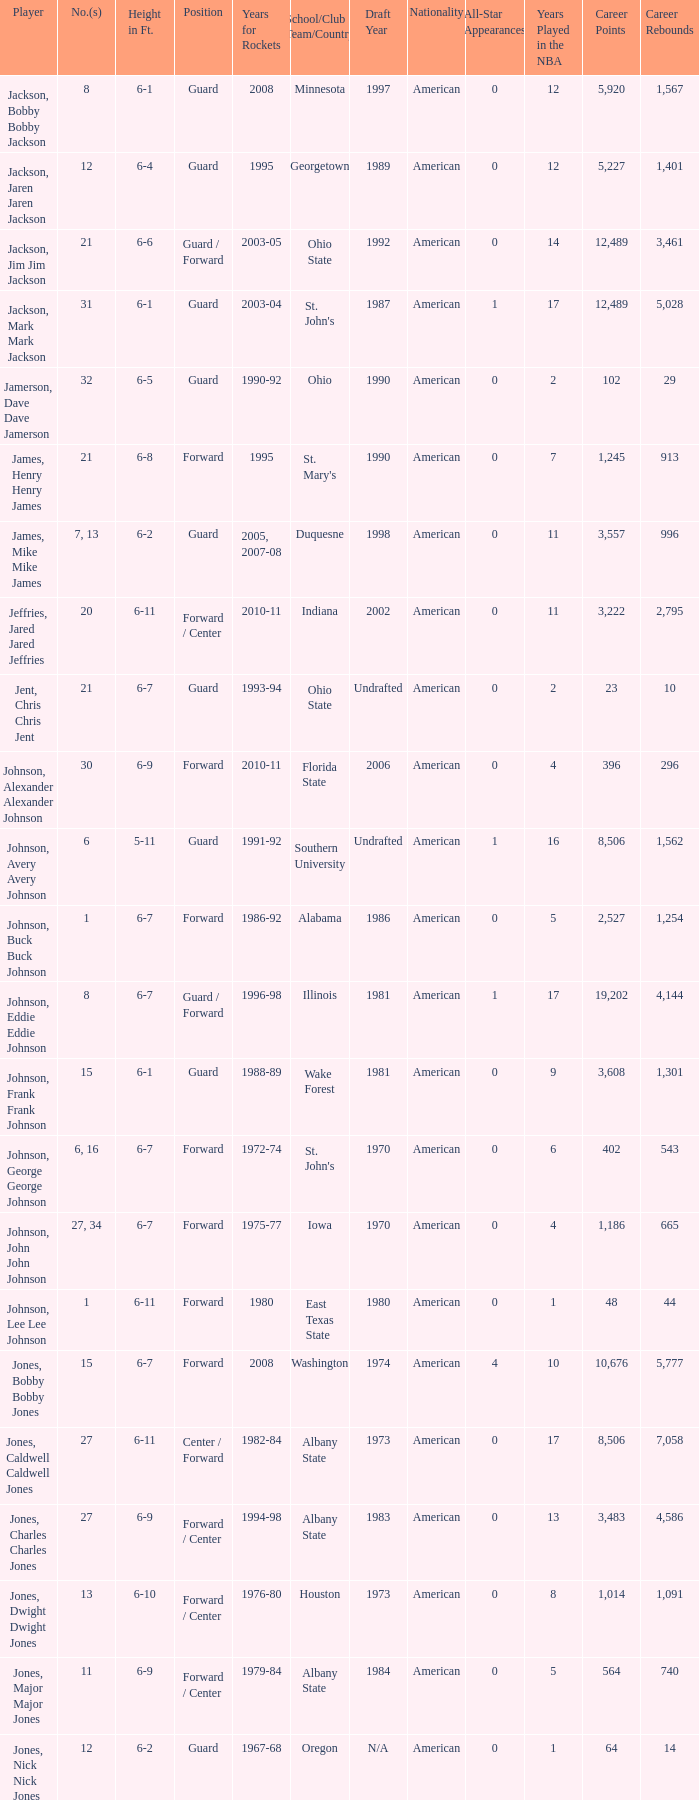Which number corresponds to the player that went to southern university? 6.0. 